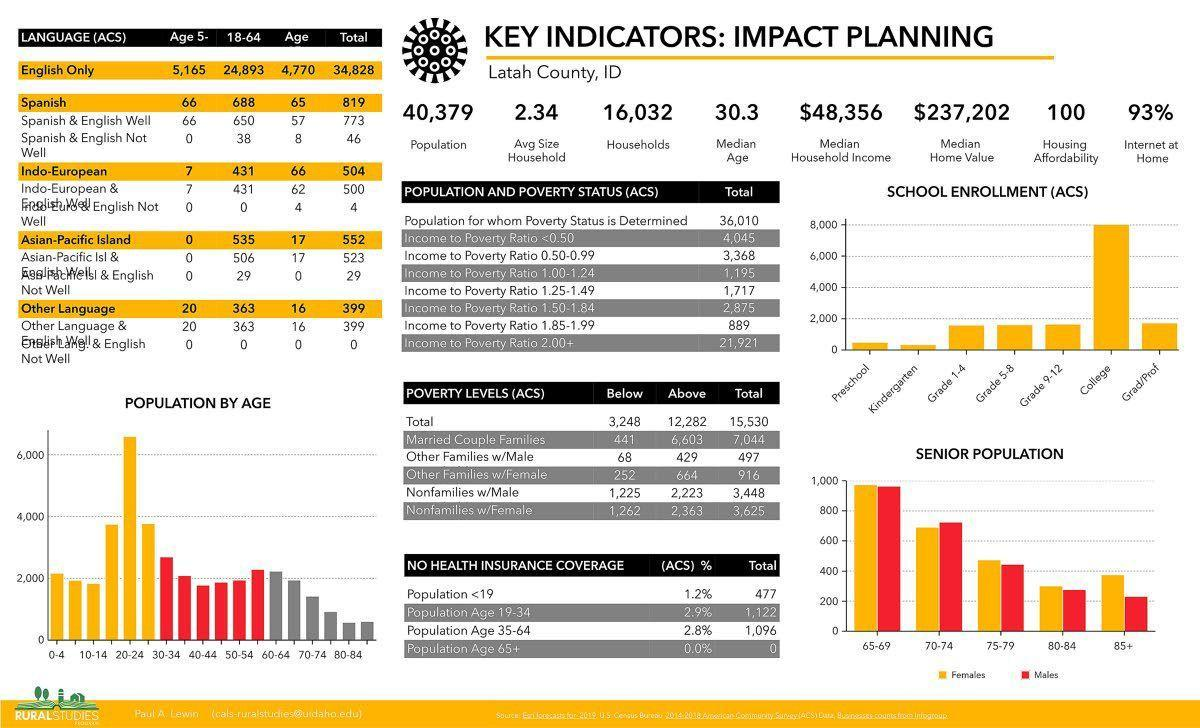Specify some key components in this picture. There are 300 females in the age group of 80-84 in the senior population. All grades from Grade 1 to Grade 12 have the same number of school enrollments. The median age is 30.3 years old. There are 16,032 households in the area. The median home value is $237,202. 